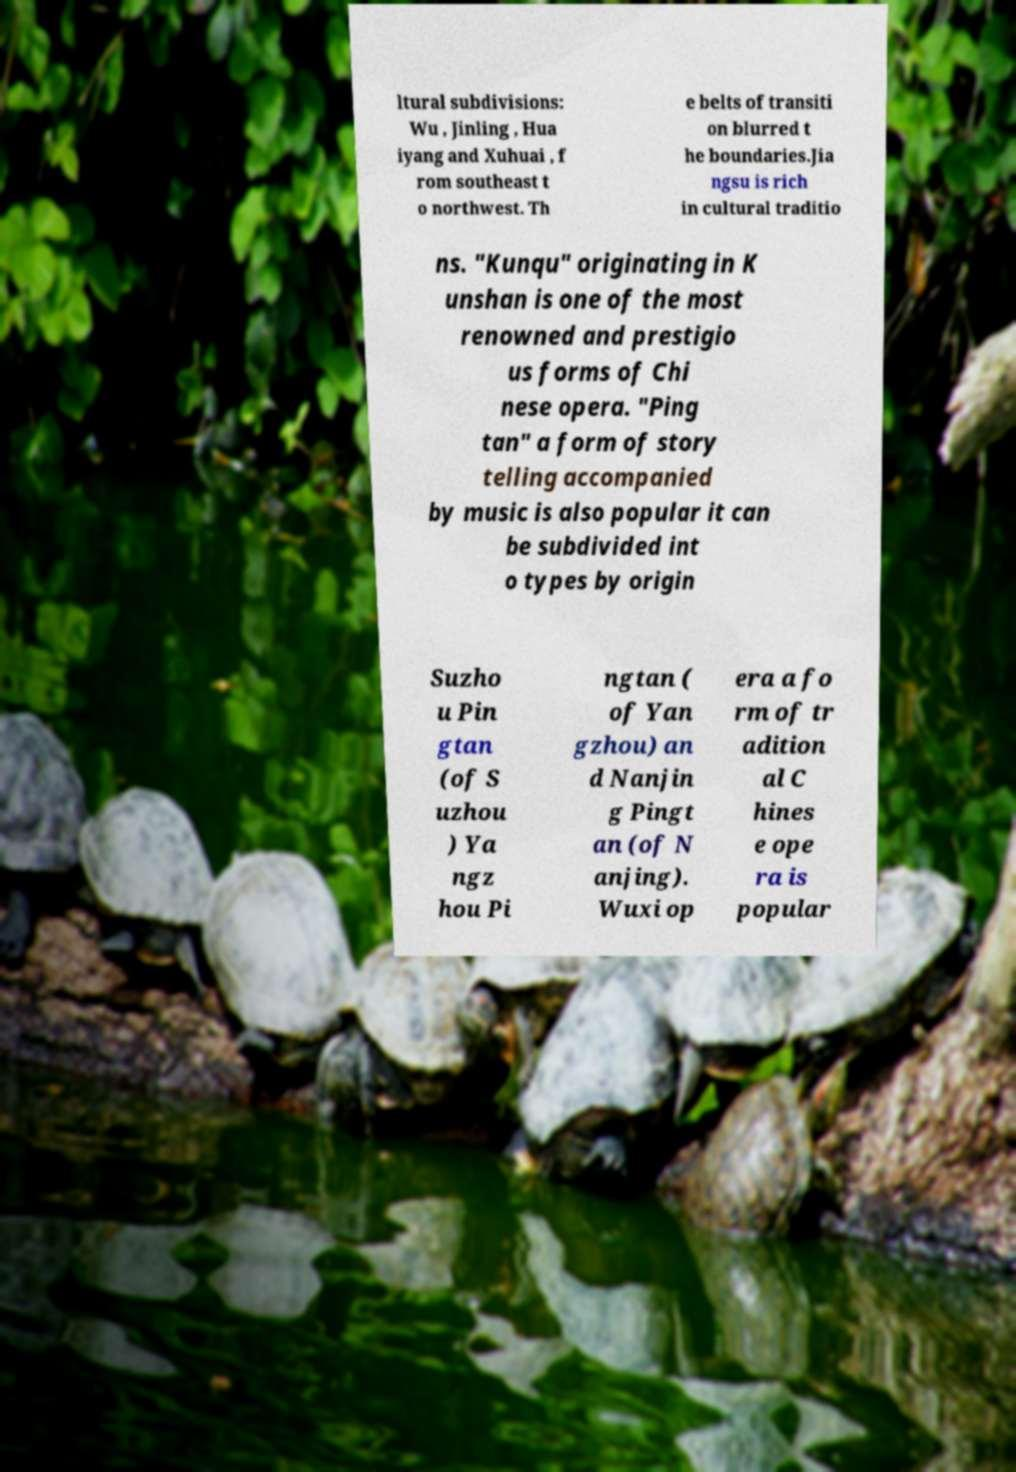For documentation purposes, I need the text within this image transcribed. Could you provide that? ltural subdivisions: Wu , Jinling , Hua iyang and Xuhuai , f rom southeast t o northwest. Th e belts of transiti on blurred t he boundaries.Jia ngsu is rich in cultural traditio ns. "Kunqu" originating in K unshan is one of the most renowned and prestigio us forms of Chi nese opera. "Ping tan" a form of story telling accompanied by music is also popular it can be subdivided int o types by origin Suzho u Pin gtan (of S uzhou ) Ya ngz hou Pi ngtan ( of Yan gzhou) an d Nanjin g Pingt an (of N anjing). Wuxi op era a fo rm of tr adition al C hines e ope ra is popular 